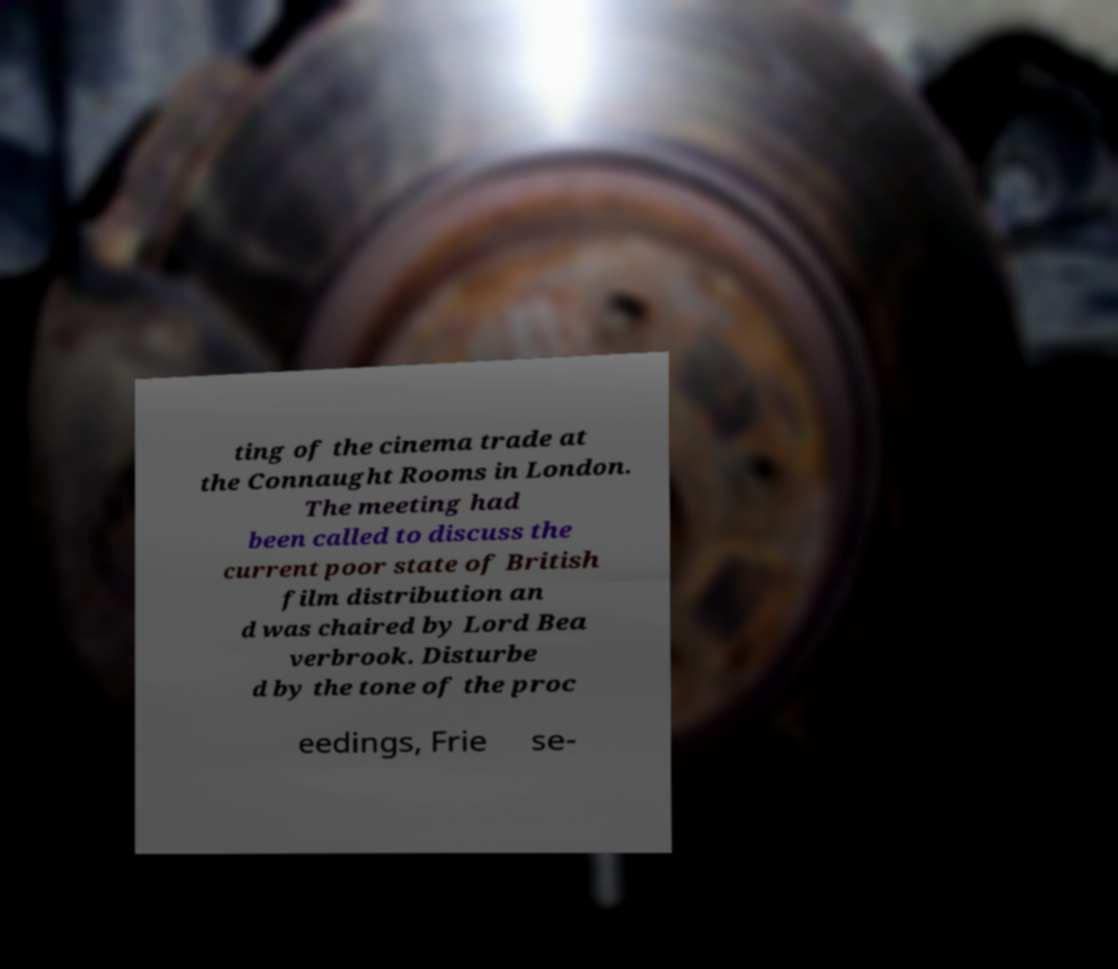Could you assist in decoding the text presented in this image and type it out clearly? ting of the cinema trade at the Connaught Rooms in London. The meeting had been called to discuss the current poor state of British film distribution an d was chaired by Lord Bea verbrook. Disturbe d by the tone of the proc eedings, Frie se- 